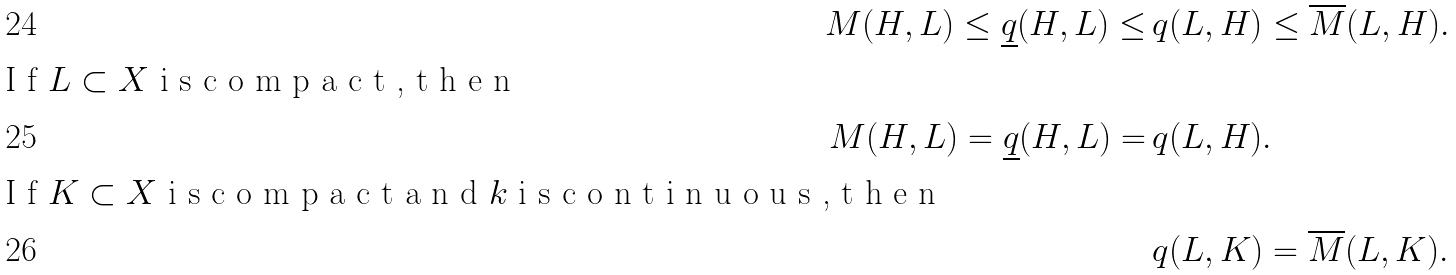Convert formula to latex. <formula><loc_0><loc_0><loc_500><loc_500>M ( H , L ) \leq \underline { q } ( H , L ) \leq & \, q ( L , H ) \leq \overline { M } ( L , H ) . \\ \intertext { I f $ L \subset X $ i s c o m p a c t , t h e n } M ( H , L ) = \underline { q } ( H , L ) = & \, q ( L , H ) . \\ \intertext { I f $ K \subset X $ i s c o m p a c t a n d $ k $ i s c o n t i n u o u s , t h e n } & \, q ( L , K ) = \overline { M } ( L , K ) .</formula> 